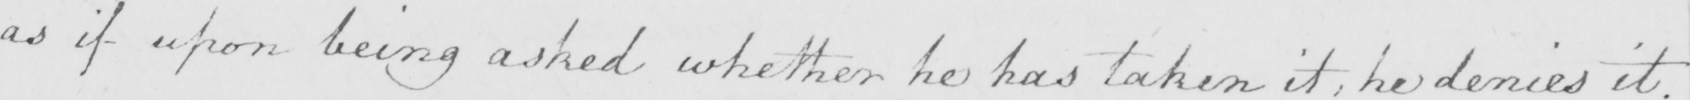Please provide the text content of this handwritten line. as if upon being asked whether he has taken it , he denies it . 